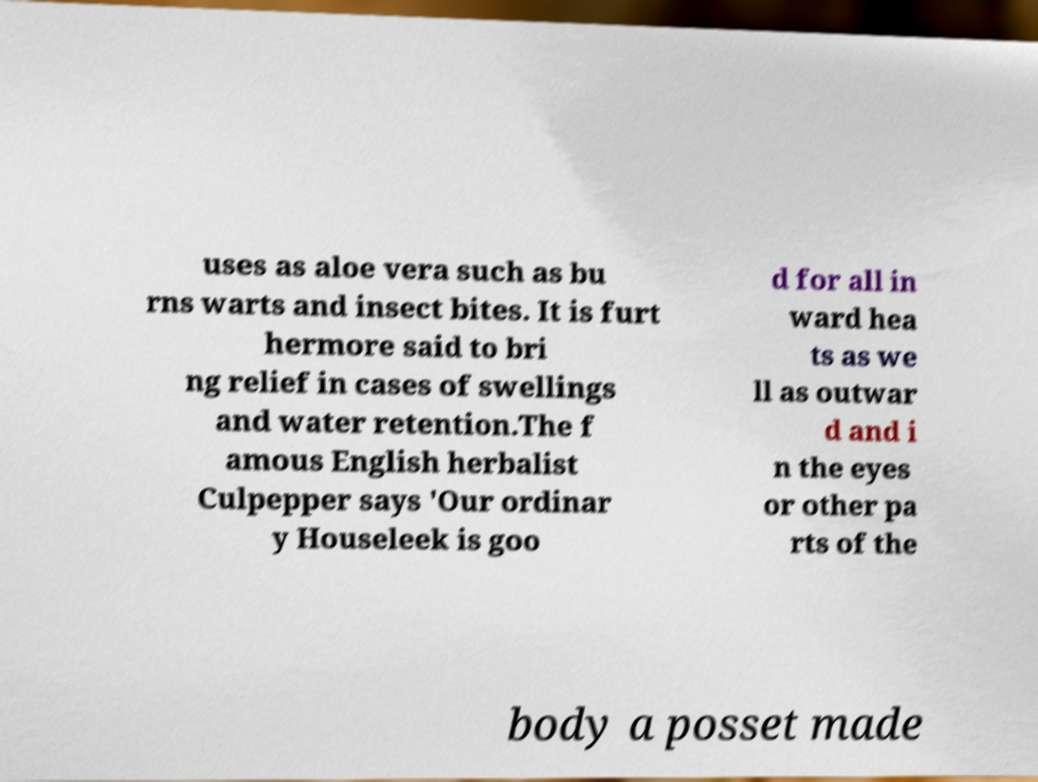Can you read and provide the text displayed in the image?This photo seems to have some interesting text. Can you extract and type it out for me? uses as aloe vera such as bu rns warts and insect bites. It is furt hermore said to bri ng relief in cases of swellings and water retention.The f amous English herbalist Culpepper says 'Our ordinar y Houseleek is goo d for all in ward hea ts as we ll as outwar d and i n the eyes or other pa rts of the body a posset made 